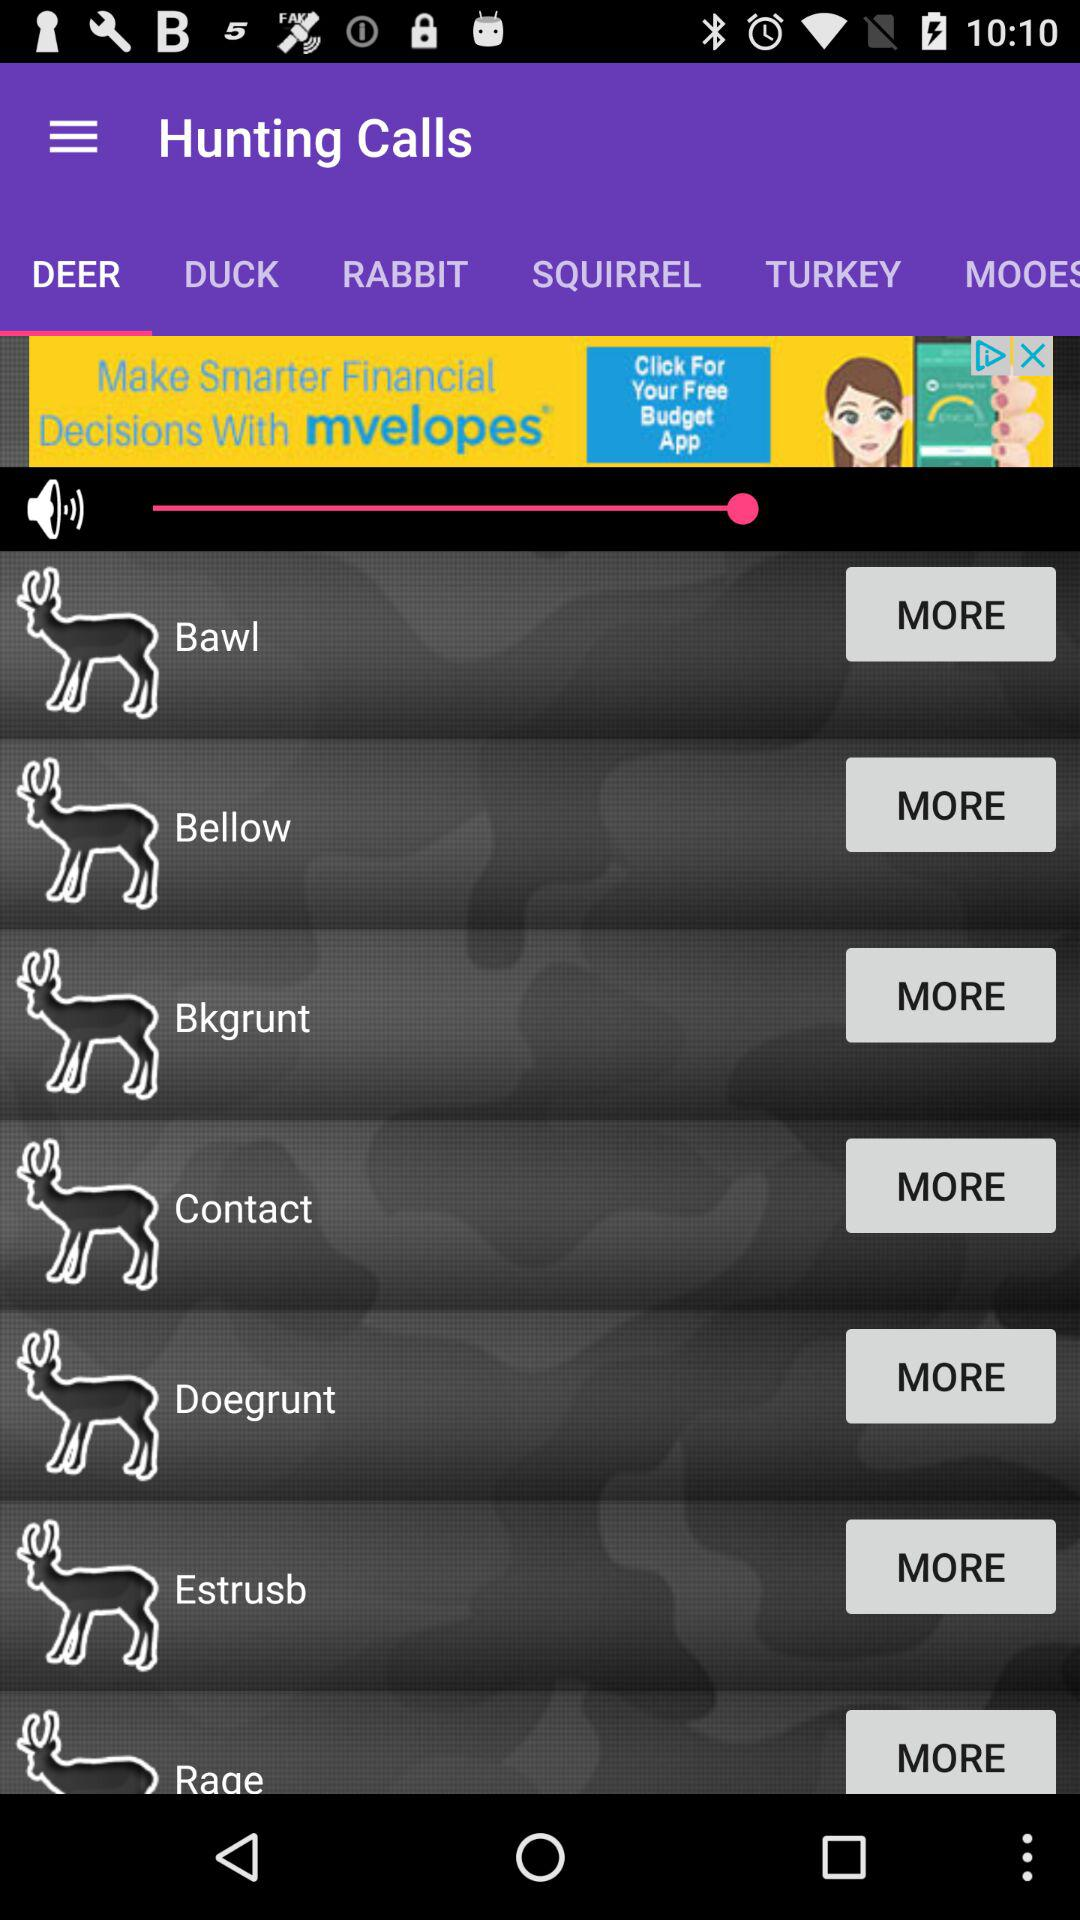What are the different types of "Hunting Calls" in "DEER"? The different types of "Hunting Calls" in "DEER" are "Bawl", "Bellow", "Bkgrunt", "Contact", "Doegrunt", "Estrusb" and "Rage". 